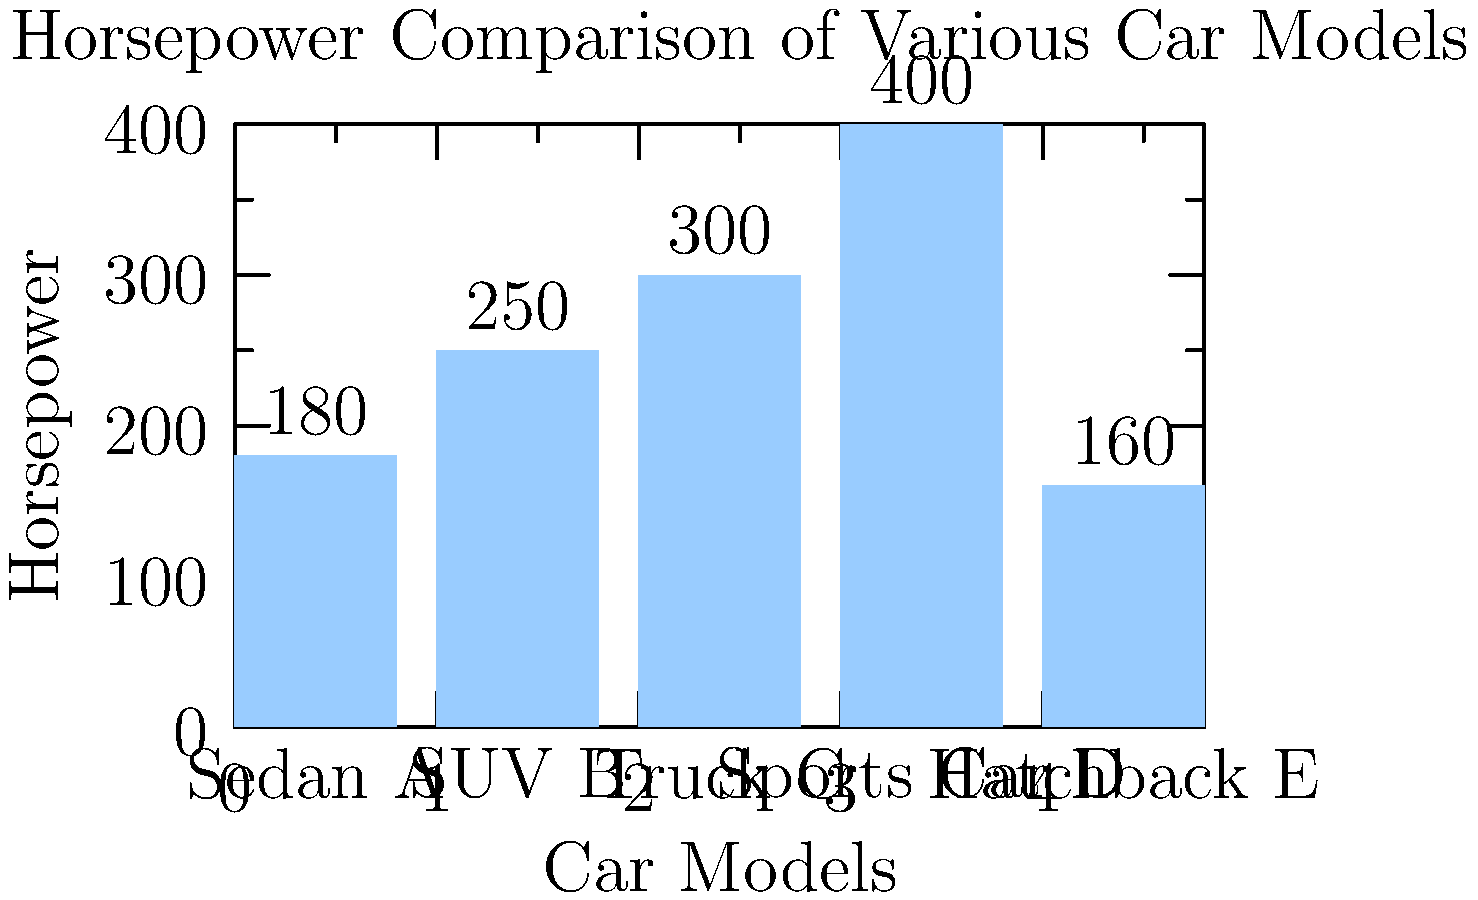As an automotive technician, you're analyzing the horsepower data of various car models. The bar graph shows the horsepower of five different car models. If you were to calculate the average horsepower of the three most powerful cars in this dataset, what would be the result? To solve this problem, we'll follow these steps:

1. Identify the horsepower of each car model from the graph:
   - Sedan A: 180 hp
   - SUV B: 250 hp
   - Truck C: 300 hp
   - Sports Car D: 400 hp
   - Hatchback E: 160 hp

2. Determine the three most powerful cars:
   1. Sports Car D (400 hp)
   2. Truck C (300 hp)
   3. SUV B (250 hp)

3. Calculate the average horsepower:
   $$ \text{Average} = \frac{\text{Sum of horsepower}}{\text{Number of cars}} $$
   $$ \text{Average} = \frac{400 + 300 + 250}{3} = \frac{950}{3} = 316.67 \text{ hp} $$

Therefore, the average horsepower of the three most powerful cars is approximately 316.67 hp.
Answer: 316.67 hp 